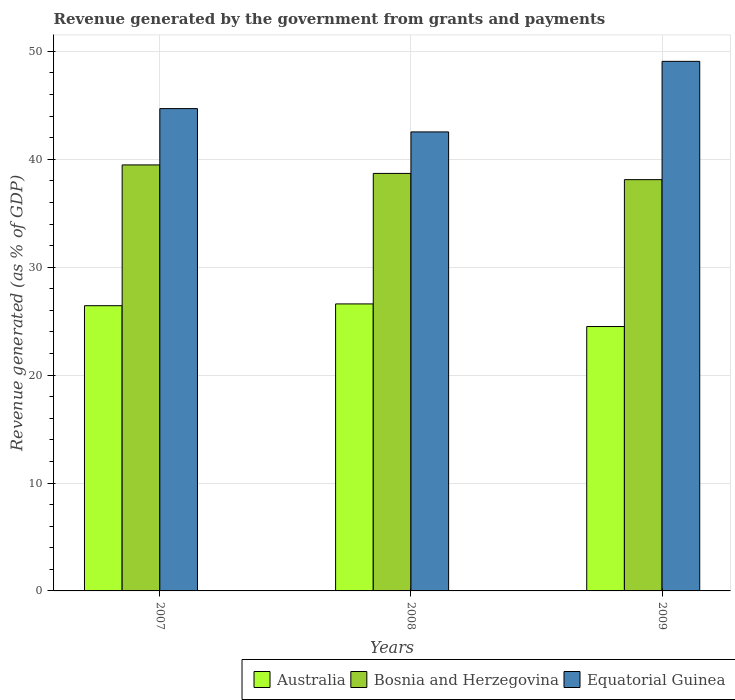How many different coloured bars are there?
Offer a terse response. 3. How many groups of bars are there?
Ensure brevity in your answer.  3. Are the number of bars per tick equal to the number of legend labels?
Your answer should be very brief. Yes. How many bars are there on the 2nd tick from the right?
Your response must be concise. 3. What is the label of the 1st group of bars from the left?
Make the answer very short. 2007. In how many cases, is the number of bars for a given year not equal to the number of legend labels?
Provide a short and direct response. 0. What is the revenue generated by the government in Equatorial Guinea in 2009?
Offer a very short reply. 49.07. Across all years, what is the maximum revenue generated by the government in Equatorial Guinea?
Provide a short and direct response. 49.07. Across all years, what is the minimum revenue generated by the government in Bosnia and Herzegovina?
Offer a very short reply. 38.11. In which year was the revenue generated by the government in Equatorial Guinea maximum?
Your response must be concise. 2009. In which year was the revenue generated by the government in Equatorial Guinea minimum?
Ensure brevity in your answer.  2008. What is the total revenue generated by the government in Bosnia and Herzegovina in the graph?
Your answer should be very brief. 116.28. What is the difference between the revenue generated by the government in Australia in 2008 and that in 2009?
Offer a terse response. 2.09. What is the difference between the revenue generated by the government in Bosnia and Herzegovina in 2008 and the revenue generated by the government in Australia in 2009?
Give a very brief answer. 14.19. What is the average revenue generated by the government in Australia per year?
Make the answer very short. 25.84. In the year 2009, what is the difference between the revenue generated by the government in Equatorial Guinea and revenue generated by the government in Australia?
Make the answer very short. 24.57. In how many years, is the revenue generated by the government in Australia greater than 40 %?
Provide a short and direct response. 0. What is the ratio of the revenue generated by the government in Equatorial Guinea in 2007 to that in 2009?
Offer a very short reply. 0.91. Is the revenue generated by the government in Australia in 2008 less than that in 2009?
Your answer should be compact. No. What is the difference between the highest and the second highest revenue generated by the government in Equatorial Guinea?
Ensure brevity in your answer.  4.38. What is the difference between the highest and the lowest revenue generated by the government in Equatorial Guinea?
Your answer should be very brief. 6.54. In how many years, is the revenue generated by the government in Australia greater than the average revenue generated by the government in Australia taken over all years?
Provide a succinct answer. 2. What does the 3rd bar from the right in 2009 represents?
Offer a very short reply. Australia. Is it the case that in every year, the sum of the revenue generated by the government in Australia and revenue generated by the government in Equatorial Guinea is greater than the revenue generated by the government in Bosnia and Herzegovina?
Keep it short and to the point. Yes. How many bars are there?
Provide a short and direct response. 9. Are all the bars in the graph horizontal?
Offer a very short reply. No. How many years are there in the graph?
Your answer should be compact. 3. What is the difference between two consecutive major ticks on the Y-axis?
Make the answer very short. 10. Are the values on the major ticks of Y-axis written in scientific E-notation?
Provide a short and direct response. No. Does the graph contain any zero values?
Make the answer very short. No. What is the title of the graph?
Your response must be concise. Revenue generated by the government from grants and payments. Does "Austria" appear as one of the legend labels in the graph?
Offer a terse response. No. What is the label or title of the X-axis?
Offer a terse response. Years. What is the label or title of the Y-axis?
Your answer should be very brief. Revenue generated (as % of GDP). What is the Revenue generated (as % of GDP) in Australia in 2007?
Provide a short and direct response. 26.43. What is the Revenue generated (as % of GDP) of Bosnia and Herzegovina in 2007?
Your response must be concise. 39.48. What is the Revenue generated (as % of GDP) in Equatorial Guinea in 2007?
Make the answer very short. 44.7. What is the Revenue generated (as % of GDP) in Australia in 2008?
Keep it short and to the point. 26.6. What is the Revenue generated (as % of GDP) in Bosnia and Herzegovina in 2008?
Offer a terse response. 38.69. What is the Revenue generated (as % of GDP) of Equatorial Guinea in 2008?
Give a very brief answer. 42.54. What is the Revenue generated (as % of GDP) in Australia in 2009?
Your answer should be very brief. 24.5. What is the Revenue generated (as % of GDP) of Bosnia and Herzegovina in 2009?
Your answer should be very brief. 38.11. What is the Revenue generated (as % of GDP) in Equatorial Guinea in 2009?
Ensure brevity in your answer.  49.07. Across all years, what is the maximum Revenue generated (as % of GDP) in Australia?
Ensure brevity in your answer.  26.6. Across all years, what is the maximum Revenue generated (as % of GDP) in Bosnia and Herzegovina?
Make the answer very short. 39.48. Across all years, what is the maximum Revenue generated (as % of GDP) in Equatorial Guinea?
Make the answer very short. 49.07. Across all years, what is the minimum Revenue generated (as % of GDP) in Australia?
Your answer should be very brief. 24.5. Across all years, what is the minimum Revenue generated (as % of GDP) of Bosnia and Herzegovina?
Offer a terse response. 38.11. Across all years, what is the minimum Revenue generated (as % of GDP) in Equatorial Guinea?
Provide a succinct answer. 42.54. What is the total Revenue generated (as % of GDP) in Australia in the graph?
Give a very brief answer. 77.53. What is the total Revenue generated (as % of GDP) of Bosnia and Herzegovina in the graph?
Provide a short and direct response. 116.28. What is the total Revenue generated (as % of GDP) in Equatorial Guinea in the graph?
Provide a succinct answer. 136.31. What is the difference between the Revenue generated (as % of GDP) in Australia in 2007 and that in 2008?
Your response must be concise. -0.17. What is the difference between the Revenue generated (as % of GDP) in Bosnia and Herzegovina in 2007 and that in 2008?
Give a very brief answer. 0.79. What is the difference between the Revenue generated (as % of GDP) of Equatorial Guinea in 2007 and that in 2008?
Your answer should be very brief. 2.16. What is the difference between the Revenue generated (as % of GDP) of Australia in 2007 and that in 2009?
Your answer should be compact. 1.93. What is the difference between the Revenue generated (as % of GDP) of Bosnia and Herzegovina in 2007 and that in 2009?
Provide a short and direct response. 1.36. What is the difference between the Revenue generated (as % of GDP) of Equatorial Guinea in 2007 and that in 2009?
Keep it short and to the point. -4.38. What is the difference between the Revenue generated (as % of GDP) in Australia in 2008 and that in 2009?
Keep it short and to the point. 2.09. What is the difference between the Revenue generated (as % of GDP) in Bosnia and Herzegovina in 2008 and that in 2009?
Your answer should be compact. 0.58. What is the difference between the Revenue generated (as % of GDP) of Equatorial Guinea in 2008 and that in 2009?
Make the answer very short. -6.54. What is the difference between the Revenue generated (as % of GDP) of Australia in 2007 and the Revenue generated (as % of GDP) of Bosnia and Herzegovina in 2008?
Your answer should be compact. -12.26. What is the difference between the Revenue generated (as % of GDP) in Australia in 2007 and the Revenue generated (as % of GDP) in Equatorial Guinea in 2008?
Your answer should be very brief. -16.1. What is the difference between the Revenue generated (as % of GDP) in Bosnia and Herzegovina in 2007 and the Revenue generated (as % of GDP) in Equatorial Guinea in 2008?
Offer a very short reply. -3.06. What is the difference between the Revenue generated (as % of GDP) in Australia in 2007 and the Revenue generated (as % of GDP) in Bosnia and Herzegovina in 2009?
Offer a terse response. -11.68. What is the difference between the Revenue generated (as % of GDP) of Australia in 2007 and the Revenue generated (as % of GDP) of Equatorial Guinea in 2009?
Offer a very short reply. -22.64. What is the difference between the Revenue generated (as % of GDP) of Bosnia and Herzegovina in 2007 and the Revenue generated (as % of GDP) of Equatorial Guinea in 2009?
Give a very brief answer. -9.6. What is the difference between the Revenue generated (as % of GDP) in Australia in 2008 and the Revenue generated (as % of GDP) in Bosnia and Herzegovina in 2009?
Keep it short and to the point. -11.52. What is the difference between the Revenue generated (as % of GDP) of Australia in 2008 and the Revenue generated (as % of GDP) of Equatorial Guinea in 2009?
Your answer should be compact. -22.48. What is the difference between the Revenue generated (as % of GDP) in Bosnia and Herzegovina in 2008 and the Revenue generated (as % of GDP) in Equatorial Guinea in 2009?
Provide a succinct answer. -10.38. What is the average Revenue generated (as % of GDP) in Australia per year?
Keep it short and to the point. 25.84. What is the average Revenue generated (as % of GDP) of Bosnia and Herzegovina per year?
Provide a short and direct response. 38.76. What is the average Revenue generated (as % of GDP) of Equatorial Guinea per year?
Provide a short and direct response. 45.44. In the year 2007, what is the difference between the Revenue generated (as % of GDP) in Australia and Revenue generated (as % of GDP) in Bosnia and Herzegovina?
Provide a short and direct response. -13.05. In the year 2007, what is the difference between the Revenue generated (as % of GDP) of Australia and Revenue generated (as % of GDP) of Equatorial Guinea?
Your answer should be compact. -18.27. In the year 2007, what is the difference between the Revenue generated (as % of GDP) in Bosnia and Herzegovina and Revenue generated (as % of GDP) in Equatorial Guinea?
Your answer should be compact. -5.22. In the year 2008, what is the difference between the Revenue generated (as % of GDP) in Australia and Revenue generated (as % of GDP) in Bosnia and Herzegovina?
Make the answer very short. -12.09. In the year 2008, what is the difference between the Revenue generated (as % of GDP) of Australia and Revenue generated (as % of GDP) of Equatorial Guinea?
Give a very brief answer. -15.94. In the year 2008, what is the difference between the Revenue generated (as % of GDP) of Bosnia and Herzegovina and Revenue generated (as % of GDP) of Equatorial Guinea?
Make the answer very short. -3.85. In the year 2009, what is the difference between the Revenue generated (as % of GDP) in Australia and Revenue generated (as % of GDP) in Bosnia and Herzegovina?
Your response must be concise. -13.61. In the year 2009, what is the difference between the Revenue generated (as % of GDP) in Australia and Revenue generated (as % of GDP) in Equatorial Guinea?
Provide a succinct answer. -24.57. In the year 2009, what is the difference between the Revenue generated (as % of GDP) of Bosnia and Herzegovina and Revenue generated (as % of GDP) of Equatorial Guinea?
Give a very brief answer. -10.96. What is the ratio of the Revenue generated (as % of GDP) in Bosnia and Herzegovina in 2007 to that in 2008?
Offer a very short reply. 1.02. What is the ratio of the Revenue generated (as % of GDP) in Equatorial Guinea in 2007 to that in 2008?
Offer a terse response. 1.05. What is the ratio of the Revenue generated (as % of GDP) in Australia in 2007 to that in 2009?
Provide a short and direct response. 1.08. What is the ratio of the Revenue generated (as % of GDP) of Bosnia and Herzegovina in 2007 to that in 2009?
Ensure brevity in your answer.  1.04. What is the ratio of the Revenue generated (as % of GDP) of Equatorial Guinea in 2007 to that in 2009?
Your response must be concise. 0.91. What is the ratio of the Revenue generated (as % of GDP) of Australia in 2008 to that in 2009?
Provide a short and direct response. 1.09. What is the ratio of the Revenue generated (as % of GDP) in Bosnia and Herzegovina in 2008 to that in 2009?
Give a very brief answer. 1.02. What is the ratio of the Revenue generated (as % of GDP) of Equatorial Guinea in 2008 to that in 2009?
Provide a short and direct response. 0.87. What is the difference between the highest and the second highest Revenue generated (as % of GDP) of Australia?
Provide a short and direct response. 0.17. What is the difference between the highest and the second highest Revenue generated (as % of GDP) of Bosnia and Herzegovina?
Your answer should be compact. 0.79. What is the difference between the highest and the second highest Revenue generated (as % of GDP) in Equatorial Guinea?
Offer a very short reply. 4.38. What is the difference between the highest and the lowest Revenue generated (as % of GDP) of Australia?
Your answer should be compact. 2.09. What is the difference between the highest and the lowest Revenue generated (as % of GDP) in Bosnia and Herzegovina?
Your response must be concise. 1.36. What is the difference between the highest and the lowest Revenue generated (as % of GDP) in Equatorial Guinea?
Your answer should be compact. 6.54. 